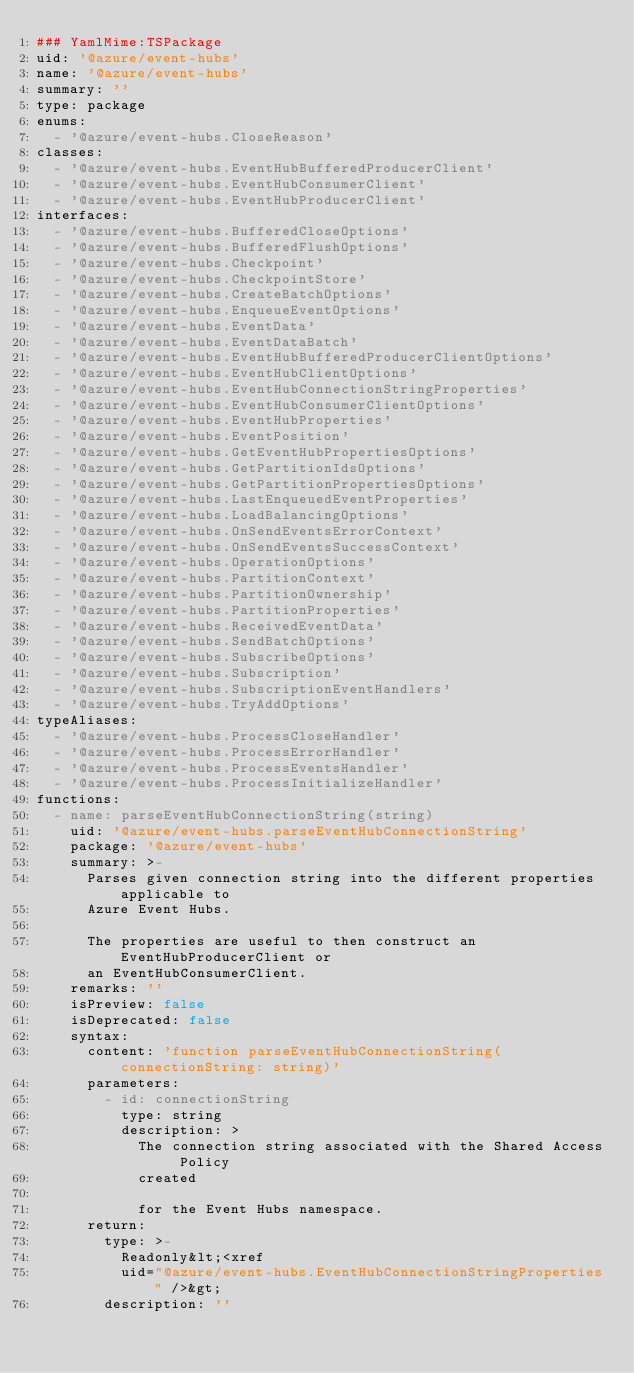<code> <loc_0><loc_0><loc_500><loc_500><_YAML_>### YamlMime:TSPackage
uid: '@azure/event-hubs'
name: '@azure/event-hubs'
summary: ''
type: package
enums:
  - '@azure/event-hubs.CloseReason'
classes:
  - '@azure/event-hubs.EventHubBufferedProducerClient'
  - '@azure/event-hubs.EventHubConsumerClient'
  - '@azure/event-hubs.EventHubProducerClient'
interfaces:
  - '@azure/event-hubs.BufferedCloseOptions'
  - '@azure/event-hubs.BufferedFlushOptions'
  - '@azure/event-hubs.Checkpoint'
  - '@azure/event-hubs.CheckpointStore'
  - '@azure/event-hubs.CreateBatchOptions'
  - '@azure/event-hubs.EnqueueEventOptions'
  - '@azure/event-hubs.EventData'
  - '@azure/event-hubs.EventDataBatch'
  - '@azure/event-hubs.EventHubBufferedProducerClientOptions'
  - '@azure/event-hubs.EventHubClientOptions'
  - '@azure/event-hubs.EventHubConnectionStringProperties'
  - '@azure/event-hubs.EventHubConsumerClientOptions'
  - '@azure/event-hubs.EventHubProperties'
  - '@azure/event-hubs.EventPosition'
  - '@azure/event-hubs.GetEventHubPropertiesOptions'
  - '@azure/event-hubs.GetPartitionIdsOptions'
  - '@azure/event-hubs.GetPartitionPropertiesOptions'
  - '@azure/event-hubs.LastEnqueuedEventProperties'
  - '@azure/event-hubs.LoadBalancingOptions'
  - '@azure/event-hubs.OnSendEventsErrorContext'
  - '@azure/event-hubs.OnSendEventsSuccessContext'
  - '@azure/event-hubs.OperationOptions'
  - '@azure/event-hubs.PartitionContext'
  - '@azure/event-hubs.PartitionOwnership'
  - '@azure/event-hubs.PartitionProperties'
  - '@azure/event-hubs.ReceivedEventData'
  - '@azure/event-hubs.SendBatchOptions'
  - '@azure/event-hubs.SubscribeOptions'
  - '@azure/event-hubs.Subscription'
  - '@azure/event-hubs.SubscriptionEventHandlers'
  - '@azure/event-hubs.TryAddOptions'
typeAliases:
  - '@azure/event-hubs.ProcessCloseHandler'
  - '@azure/event-hubs.ProcessErrorHandler'
  - '@azure/event-hubs.ProcessEventsHandler'
  - '@azure/event-hubs.ProcessInitializeHandler'
functions:
  - name: parseEventHubConnectionString(string)
    uid: '@azure/event-hubs.parseEventHubConnectionString'
    package: '@azure/event-hubs'
    summary: >-
      Parses given connection string into the different properties applicable to
      Azure Event Hubs.

      The properties are useful to then construct an EventHubProducerClient or
      an EventHubConsumerClient.
    remarks: ''
    isPreview: false
    isDeprecated: false
    syntax:
      content: 'function parseEventHubConnectionString(connectionString: string)'
      parameters:
        - id: connectionString
          type: string
          description: >
            The connection string associated with the Shared Access Policy
            created

            for the Event Hubs namespace.
      return:
        type: >-
          Readonly&lt;<xref
          uid="@azure/event-hubs.EventHubConnectionStringProperties" />&gt;
        description: ''
</code> 